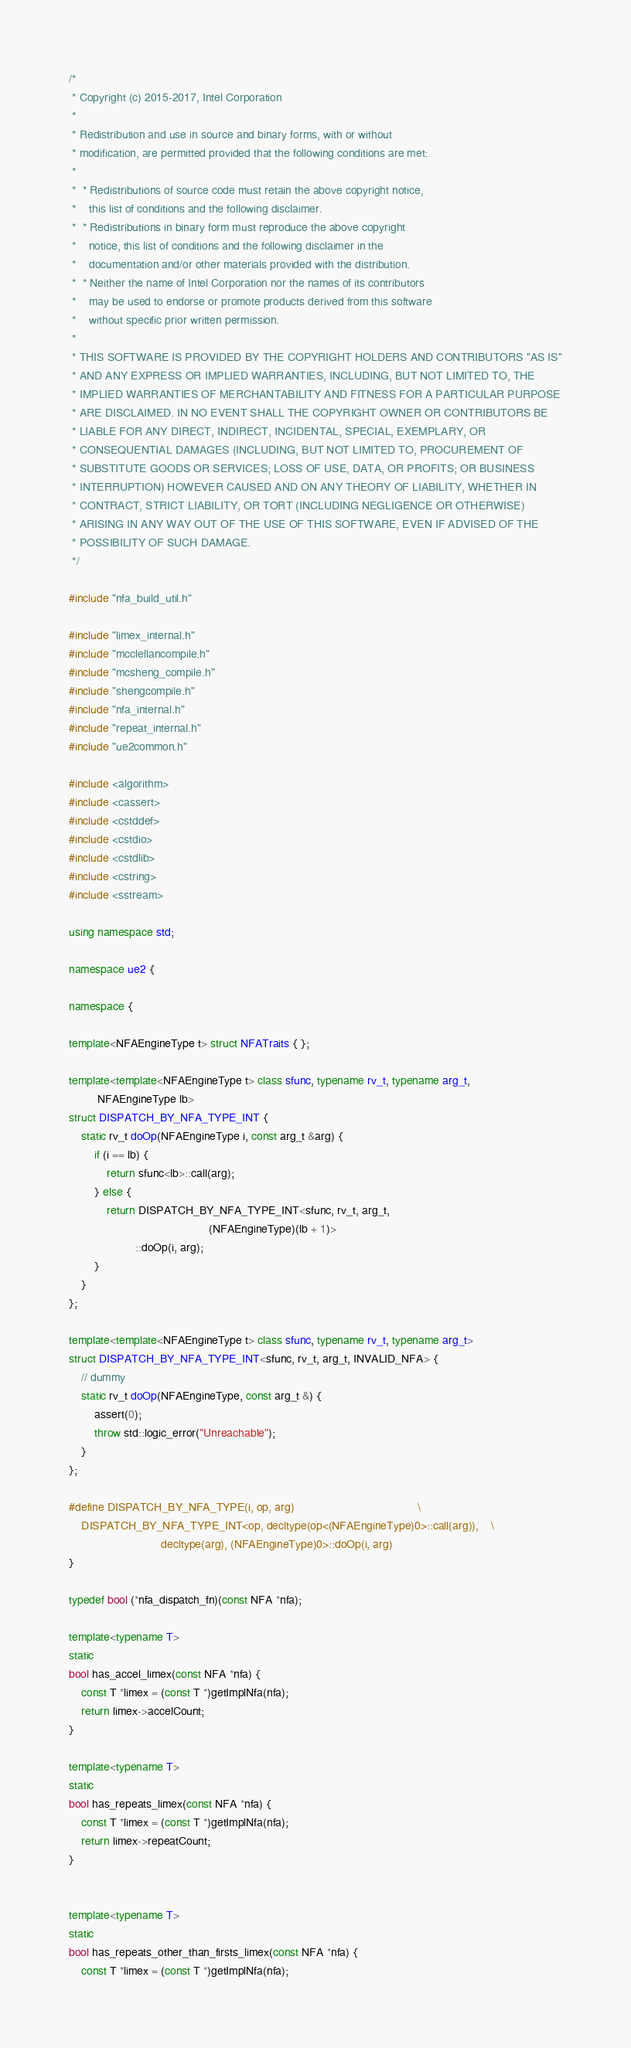<code> <loc_0><loc_0><loc_500><loc_500><_C++_>/*
 * Copyright (c) 2015-2017, Intel Corporation
 *
 * Redistribution and use in source and binary forms, with or without
 * modification, are permitted provided that the following conditions are met:
 *
 *  * Redistributions of source code must retain the above copyright notice,
 *    this list of conditions and the following disclaimer.
 *  * Redistributions in binary form must reproduce the above copyright
 *    notice, this list of conditions and the following disclaimer in the
 *    documentation and/or other materials provided with the distribution.
 *  * Neither the name of Intel Corporation nor the names of its contributors
 *    may be used to endorse or promote products derived from this software
 *    without specific prior written permission.
 *
 * THIS SOFTWARE IS PROVIDED BY THE COPYRIGHT HOLDERS AND CONTRIBUTORS "AS IS"
 * AND ANY EXPRESS OR IMPLIED WARRANTIES, INCLUDING, BUT NOT LIMITED TO, THE
 * IMPLIED WARRANTIES OF MERCHANTABILITY AND FITNESS FOR A PARTICULAR PURPOSE
 * ARE DISCLAIMED. IN NO EVENT SHALL THE COPYRIGHT OWNER OR CONTRIBUTORS BE
 * LIABLE FOR ANY DIRECT, INDIRECT, INCIDENTAL, SPECIAL, EXEMPLARY, OR
 * CONSEQUENTIAL DAMAGES (INCLUDING, BUT NOT LIMITED TO, PROCUREMENT OF
 * SUBSTITUTE GOODS OR SERVICES; LOSS OF USE, DATA, OR PROFITS; OR BUSINESS
 * INTERRUPTION) HOWEVER CAUSED AND ON ANY THEORY OF LIABILITY, WHETHER IN
 * CONTRACT, STRICT LIABILITY, OR TORT (INCLUDING NEGLIGENCE OR OTHERWISE)
 * ARISING IN ANY WAY OUT OF THE USE OF THIS SOFTWARE, EVEN IF ADVISED OF THE
 * POSSIBILITY OF SUCH DAMAGE.
 */

#include "nfa_build_util.h"

#include "limex_internal.h"
#include "mcclellancompile.h"
#include "mcsheng_compile.h"
#include "shengcompile.h"
#include "nfa_internal.h"
#include "repeat_internal.h"
#include "ue2common.h"

#include <algorithm>
#include <cassert>
#include <cstddef>
#include <cstdio>
#include <cstdlib>
#include <cstring>
#include <sstream>

using namespace std;

namespace ue2 {

namespace {

template<NFAEngineType t> struct NFATraits { };

template<template<NFAEngineType t> class sfunc, typename rv_t, typename arg_t,
         NFAEngineType lb>
struct DISPATCH_BY_NFA_TYPE_INT {
    static rv_t doOp(NFAEngineType i, const arg_t &arg) {
        if (i == lb) {
            return sfunc<lb>::call(arg);
        } else {
            return DISPATCH_BY_NFA_TYPE_INT<sfunc, rv_t, arg_t,
                                            (NFAEngineType)(lb + 1)>
                     ::doOp(i, arg);
        }
    }
};

template<template<NFAEngineType t> class sfunc, typename rv_t, typename arg_t>
struct DISPATCH_BY_NFA_TYPE_INT<sfunc, rv_t, arg_t, INVALID_NFA> {
    // dummy
    static rv_t doOp(NFAEngineType, const arg_t &) {
        assert(0);
        throw std::logic_error("Unreachable");
    }
};

#define DISPATCH_BY_NFA_TYPE(i, op, arg)                                       \
    DISPATCH_BY_NFA_TYPE_INT<op, decltype(op<(NFAEngineType)0>::call(arg)),    \
                             decltype(arg), (NFAEngineType)0>::doOp(i, arg)
}

typedef bool (*nfa_dispatch_fn)(const NFA *nfa);

template<typename T>
static
bool has_accel_limex(const NFA *nfa) {
    const T *limex = (const T *)getImplNfa(nfa);
    return limex->accelCount;
}

template<typename T>
static
bool has_repeats_limex(const NFA *nfa) {
    const T *limex = (const T *)getImplNfa(nfa);
    return limex->repeatCount;
}


template<typename T>
static
bool has_repeats_other_than_firsts_limex(const NFA *nfa) {
    const T *limex = (const T *)getImplNfa(nfa);</code> 